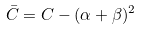<formula> <loc_0><loc_0><loc_500><loc_500>\bar { C } = C - ( \alpha + \beta ) ^ { 2 }</formula> 